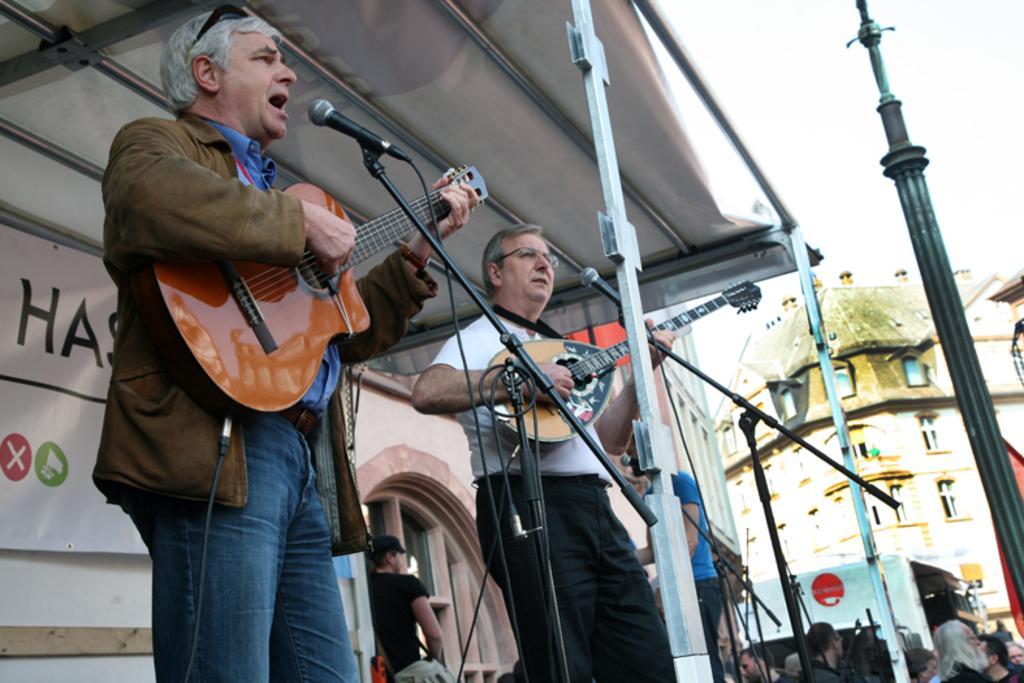Can you describe this image briefly? The picture is taken outside of the building where two people are standing on the stage and at the left corner of the picture one person is wearing a brown court and playing guitar and singing in front of the microphone and another person is standing in white shirt and playing guitar and behind them there is a building with door and one person standing at the door and at the right corner of the picture there is one building and crowd is present. 